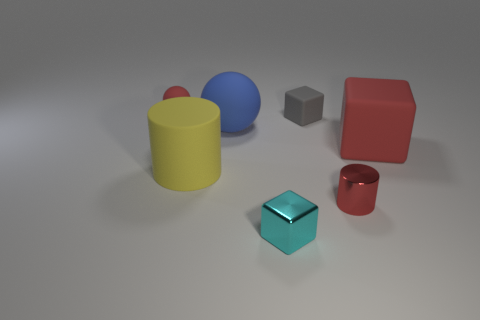What number of big spheres have the same material as the large cube?
Offer a very short reply. 1. There is a cylinder left of the shiny block that is on the left side of the small gray matte cube; is there a cylinder that is to the right of it?
Offer a terse response. Yes. What shape is the blue matte object?
Offer a very short reply. Sphere. Is the cube that is to the right of the small cylinder made of the same material as the cylinder that is right of the cyan block?
Your answer should be very brief. No. How many tiny metallic objects are the same color as the metal cylinder?
Offer a very short reply. 0. What is the shape of the tiny thing that is to the left of the gray matte cube and behind the small cyan metal block?
Your answer should be very brief. Sphere. The cube that is in front of the blue object and on the left side of the large red matte thing is what color?
Your response must be concise. Cyan. Are there more large rubber things left of the blue matte thing than tiny cyan metallic blocks right of the gray thing?
Offer a terse response. Yes. There is a big thing behind the large block; what is its color?
Make the answer very short. Blue. Is the shape of the tiny red object in front of the rubber cylinder the same as the large object that is left of the large ball?
Offer a terse response. Yes. 